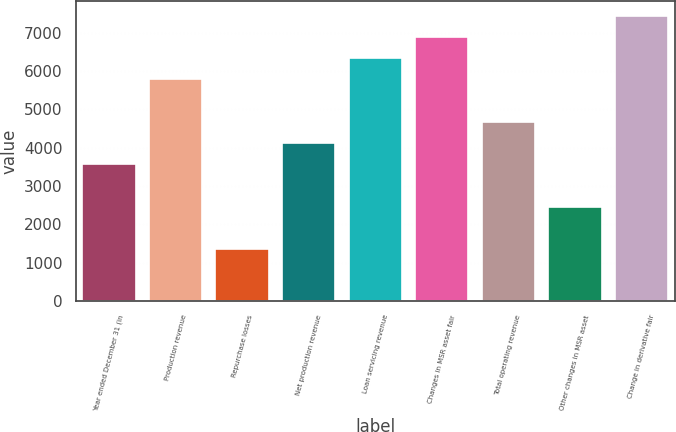<chart> <loc_0><loc_0><loc_500><loc_500><bar_chart><fcel>Year ended December 31 (in<fcel>Production revenue<fcel>Repurchase losses<fcel>Net production revenue<fcel>Loan servicing revenue<fcel>Changes in MSR asset fair<fcel>Total operating revenue<fcel>Other changes in MSR asset<fcel>Change in derivative fair<nl><fcel>3565.4<fcel>5783.8<fcel>1347<fcel>4120<fcel>6338.4<fcel>6893<fcel>4674.6<fcel>2456.2<fcel>7447.6<nl></chart> 